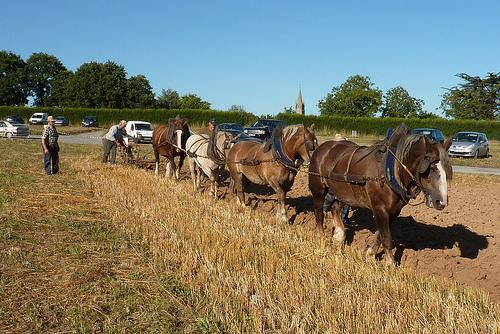What types of vehicles are parked around the field? Cars parked around the field are described as silver. Provide information about the objects in the sky and their position. There are white clouds scattered across the blue sky in various positions and sizes. Provide a brief description of the main elements in the image. There are multiple horses and a man in the field, white clouds in blue sky, cars parked around, and a background with a row of hedges. What is the activity carried out by the man in the image? The man is standing in the field, possibly directing the plowing process with the help of horses. What are the different colors of horses mentioned in the image? The horses are mentioned in brown and white colors. What are the people in the image wearing? One person in the image is wearing a straw hat, a tan cap, and a pair of blue jeans. How many horses and in what arrangement are they mentioned in the image? There are four horses in a line, along with other individual horses mentioned in various positions. What is the most prominent object in the background of the image? In the background, there is a row of well-trimmed hedges. What is the primary subject engaged in the activity related to the plowing process? There is a man directing the plow, which is hooked to horses working together in a team. Describe any distinctive feature of the lead horse. The lead horse is brown and has a white marking on its face. Is there a specific formation the horses are arranged in? They are arranged in a line. Analyze the structure and components of the depicted contraption pulled by the horses. It is a horse-drawn plow with a yoke for the working horses. In the bottom left corner of the image, does it look like a rainbow is appearing after a rainstorm? No, it's not mentioned in the image. What activity is the man near the plow performing? Directing the plow What color is the horse in the front of the image? Brown Create a short poem that captures the essence of the image. In fields of green, where horses tread, How would you describe the appearance of the lead horse? Brown with a white marking on its face. Detect the ongoing event involving the horses and the man. Plowing the field In the form of a haiku, describe the image. Horses plow the field, Describe the hedge visible in the background. It is a long, well-trimmed hedge. How many cars are parked around the field? Four Describe the scene in the image using elegant and sophisticated language. A picturesque tableau unfolds before us, revealing a bucolic landscape where a team of equines diligently plows the verdant earth, overseen by an attentive gentleman garbed in sartorial elegance. Is the man directing the plow standing in front of or beside the plow? Beside the plow Identify the types of vehicles present around the field. Cars Is the man wearing a headgear near the plow and if yes, what is it called? Yes, he is wearing a straw hat. Is there any significant building or structure visible in the image? A church steeple can be seen in the background. What color are the jeans worn by the man standing near the plow? Blue What piece of equipment is attached to the horses? Plow Create a descriptive sentence about the image using a colloquial tone. There's a whole bunch of horses plowing the field with a guy directing them, plus some cars parked around and a neat row of hedges in the back. 